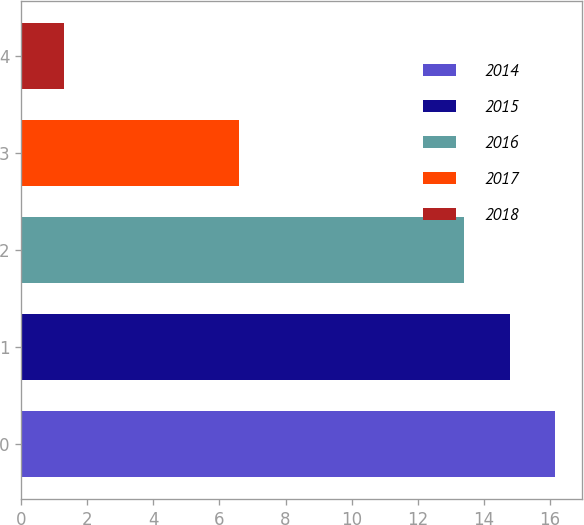<chart> <loc_0><loc_0><loc_500><loc_500><bar_chart><fcel>2014<fcel>2015<fcel>2016<fcel>2017<fcel>2018<nl><fcel>16.16<fcel>14.78<fcel>13.4<fcel>6.6<fcel>1.3<nl></chart> 